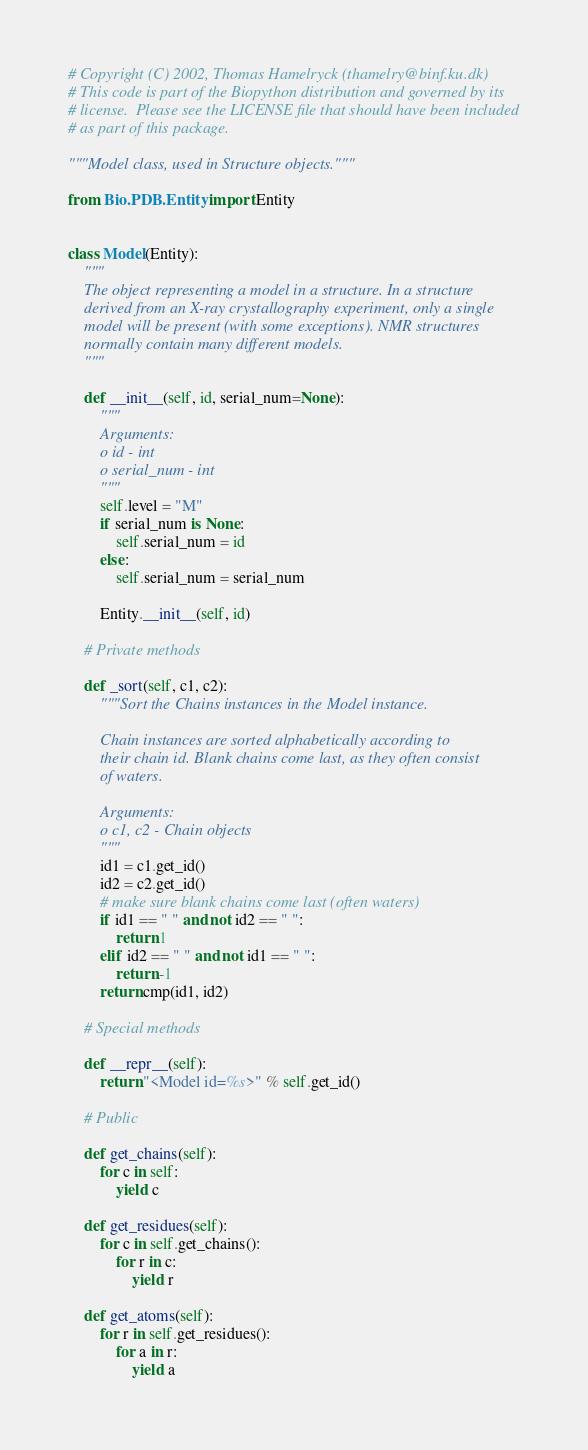<code> <loc_0><loc_0><loc_500><loc_500><_Python_># Copyright (C) 2002, Thomas Hamelryck (thamelry@binf.ku.dk)
# This code is part of the Biopython distribution and governed by its
# license.  Please see the LICENSE file that should have been included
# as part of this package.

"""Model class, used in Structure objects."""

from Bio.PDB.Entity import Entity


class Model(Entity):
    """
    The object representing a model in a structure. In a structure
    derived from an X-ray crystallography experiment, only a single
    model will be present (with some exceptions). NMR structures
    normally contain many different models.
    """

    def __init__(self, id, serial_num=None):
        """
        Arguments:
        o id - int
        o serial_num - int
        """
        self.level = "M"
        if serial_num is None:
            self.serial_num = id
        else:
            self.serial_num = serial_num

        Entity.__init__(self, id)

    # Private methods

    def _sort(self, c1, c2):
        """Sort the Chains instances in the Model instance.

        Chain instances are sorted alphabetically according to
        their chain id. Blank chains come last, as they often consist
        of waters.

        Arguments:
        o c1, c2 - Chain objects
        """
        id1 = c1.get_id()
        id2 = c2.get_id()
        # make sure blank chains come last (often waters)
        if id1 == " " and not id2 == " ":
            return 1
        elif id2 == " " and not id1 == " ":
            return -1
        return cmp(id1, id2)

    # Special methods

    def __repr__(self):
        return "<Model id=%s>" % self.get_id()

    # Public

    def get_chains(self):
        for c in self:
            yield c

    def get_residues(self):
        for c in self.get_chains():
            for r in c:
                yield r

    def get_atoms(self):
        for r in self.get_residues():
            for a in r:
                yield a
</code> 